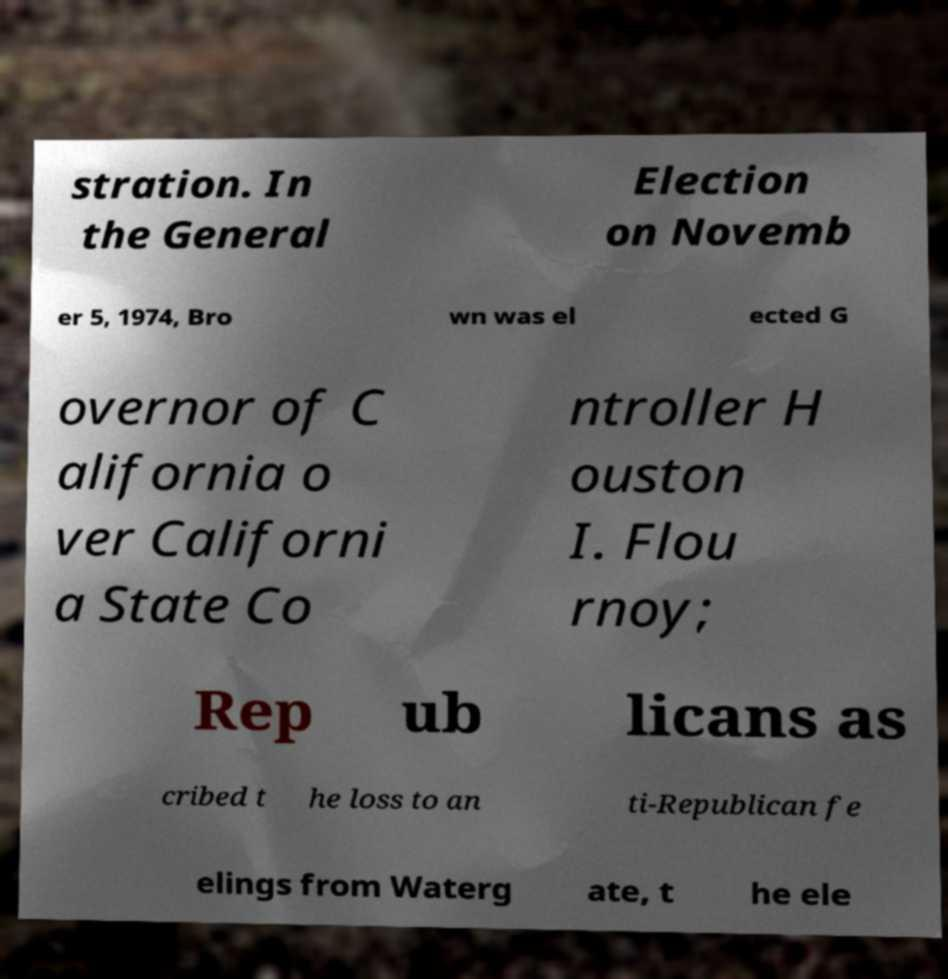Could you extract and type out the text from this image? stration. In the General Election on Novemb er 5, 1974, Bro wn was el ected G overnor of C alifornia o ver Californi a State Co ntroller H ouston I. Flou rnoy; Rep ub licans as cribed t he loss to an ti-Republican fe elings from Waterg ate, t he ele 